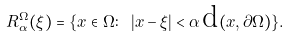<formula> <loc_0><loc_0><loc_500><loc_500>R ^ { \Omega } _ { \alpha } ( \xi ) = \{ x \in \Omega \colon \ | x - \xi | < \alpha \, \text {d} ( x , \partial \Omega ) \} .</formula> 